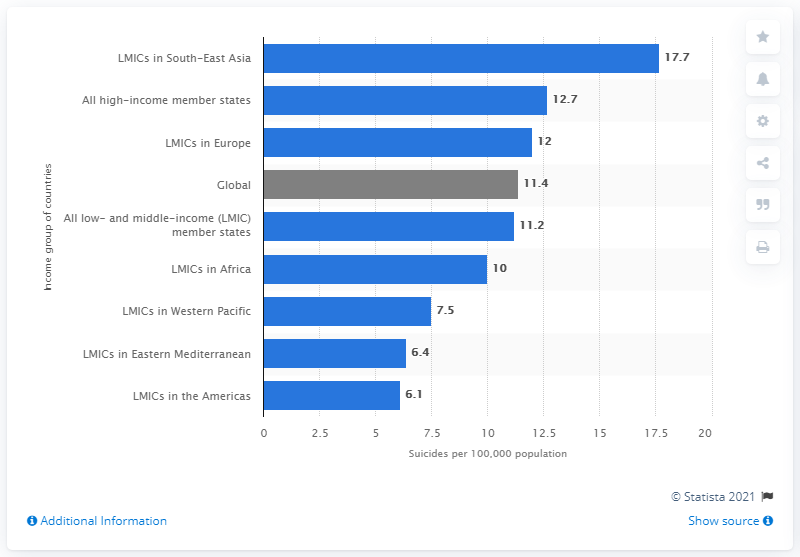Specify some key components in this picture. In 2012, the estimated global suicide rate was approximately 11.4 suicides per 100,000 people worldwide. 